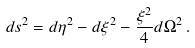<formula> <loc_0><loc_0><loc_500><loc_500>d s ^ { 2 } = d \eta ^ { 2 } - d \xi ^ { 2 } - \frac { \xi ^ { 2 } } { 4 } d \Omega ^ { 2 } \, .</formula> 